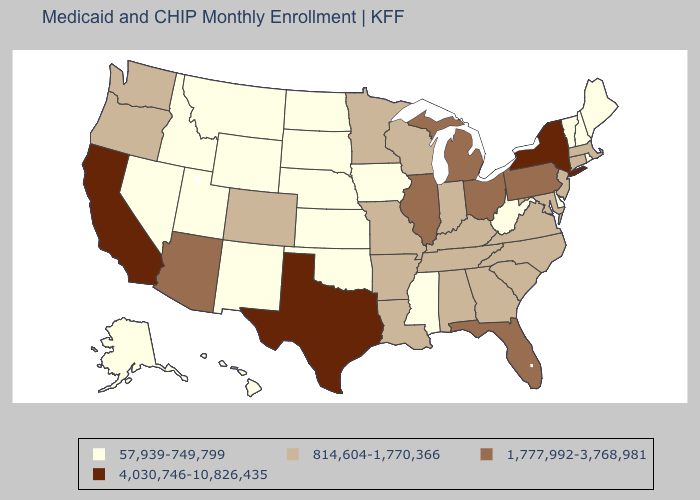Does Michigan have a higher value than Texas?
Answer briefly. No. How many symbols are there in the legend?
Concise answer only. 4. What is the value of West Virginia?
Be succinct. 57,939-749,799. What is the lowest value in states that border Michigan?
Keep it brief. 814,604-1,770,366. What is the value of Florida?
Answer briefly. 1,777,992-3,768,981. Among the states that border Tennessee , does Mississippi have the lowest value?
Give a very brief answer. Yes. What is the lowest value in the MidWest?
Short answer required. 57,939-749,799. Is the legend a continuous bar?
Write a very short answer. No. What is the lowest value in the West?
Give a very brief answer. 57,939-749,799. What is the lowest value in the Northeast?
Keep it brief. 57,939-749,799. What is the lowest value in the USA?
Concise answer only. 57,939-749,799. What is the value of New Mexico?
Be succinct. 57,939-749,799. Name the states that have a value in the range 57,939-749,799?
Quick response, please. Alaska, Delaware, Hawaii, Idaho, Iowa, Kansas, Maine, Mississippi, Montana, Nebraska, Nevada, New Hampshire, New Mexico, North Dakota, Oklahoma, Rhode Island, South Dakota, Utah, Vermont, West Virginia, Wyoming. Does Maine have the same value as Montana?
Be succinct. Yes. Does Kentucky have the lowest value in the South?
Quick response, please. No. 